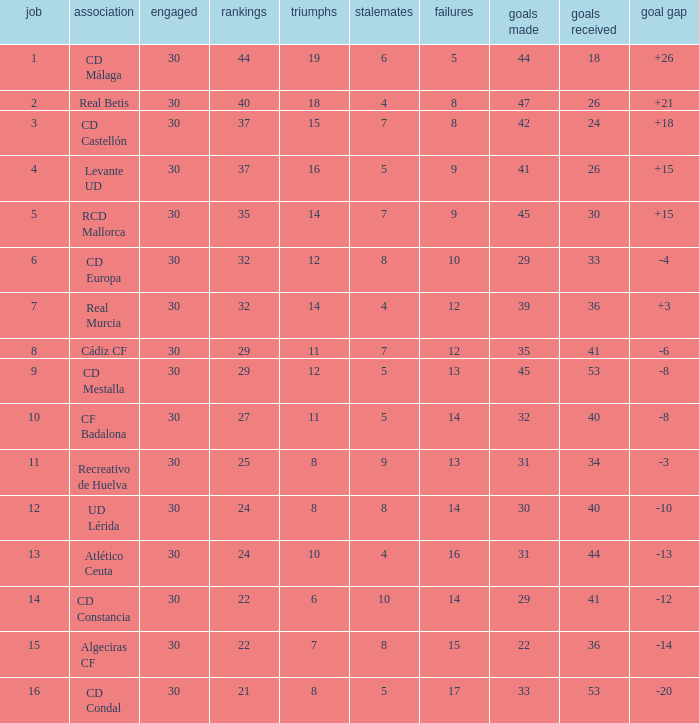What is the goals for when played is larger than 30? None. 